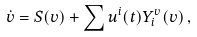Convert formula to latex. <formula><loc_0><loc_0><loc_500><loc_500>\dot { v } = S ( v ) + \sum u ^ { i } ( t ) Y _ { i } ^ { v } ( v ) \, ,</formula> 